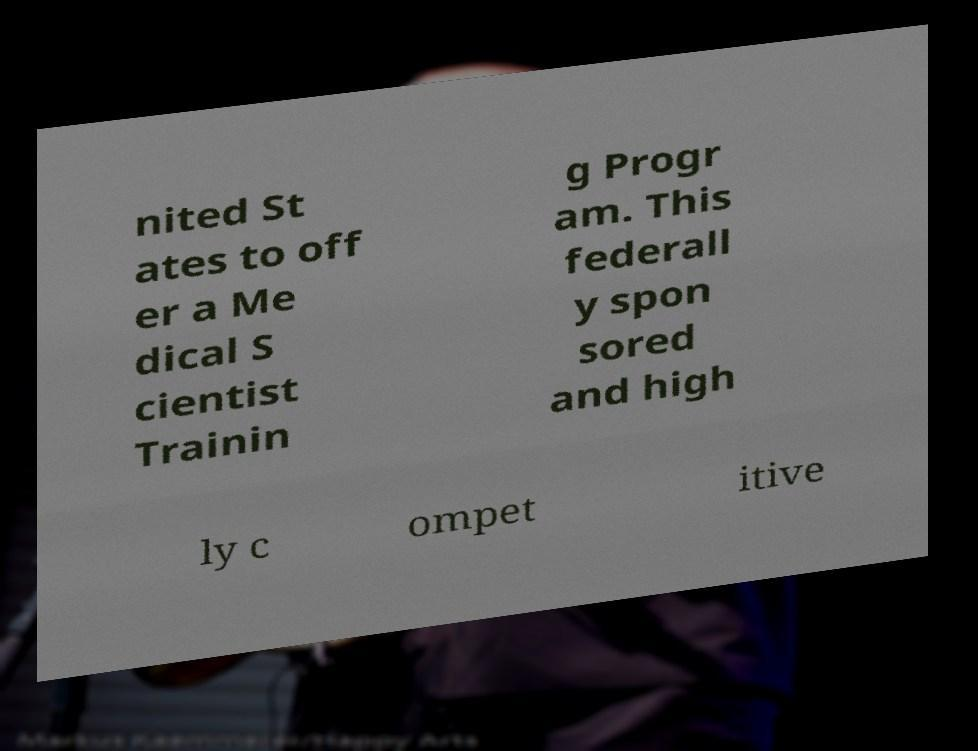What messages or text are displayed in this image? I need them in a readable, typed format. nited St ates to off er a Me dical S cientist Trainin g Progr am. This federall y spon sored and high ly c ompet itive 